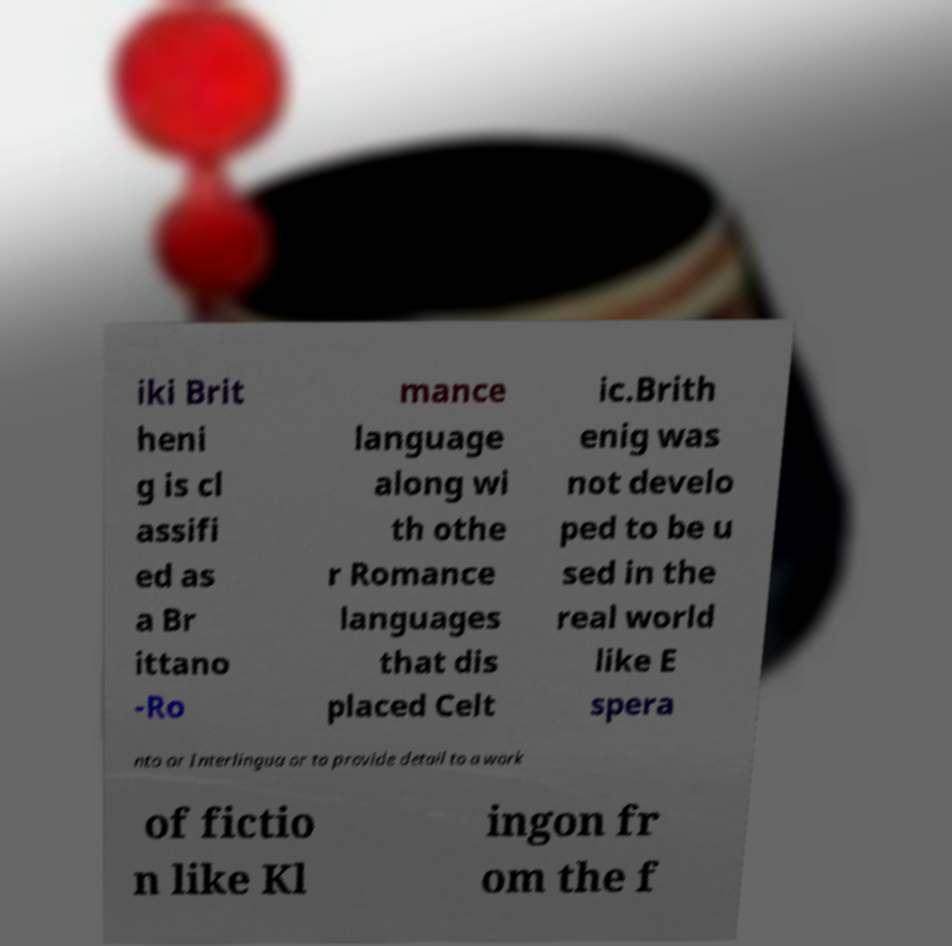I need the written content from this picture converted into text. Can you do that? iki Brit heni g is cl assifi ed as a Br ittano -Ro mance language along wi th othe r Romance languages that dis placed Celt ic.Brith enig was not develo ped to be u sed in the real world like E spera nto or Interlingua or to provide detail to a work of fictio n like Kl ingon fr om the f 